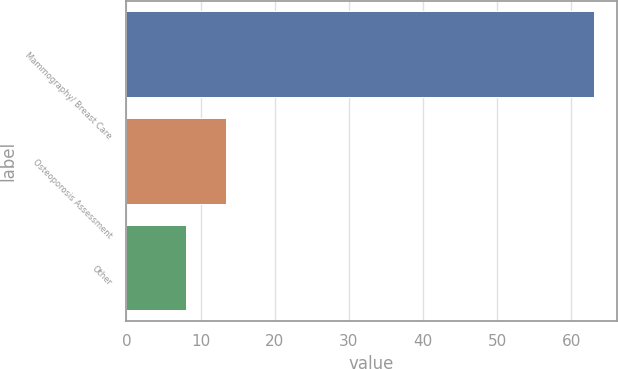Convert chart to OTSL. <chart><loc_0><loc_0><loc_500><loc_500><bar_chart><fcel>Mammography/ Breast Care<fcel>Osteoporosis Assessment<fcel>Other<nl><fcel>63<fcel>13.5<fcel>8<nl></chart> 